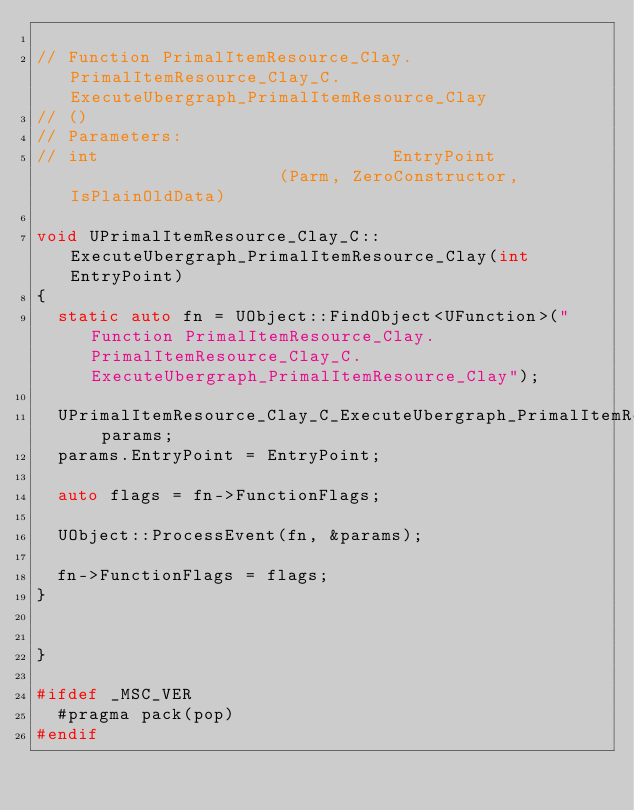<code> <loc_0><loc_0><loc_500><loc_500><_C++_>
// Function PrimalItemResource_Clay.PrimalItemResource_Clay_C.ExecuteUbergraph_PrimalItemResource_Clay
// ()
// Parameters:
// int                            EntryPoint                     (Parm, ZeroConstructor, IsPlainOldData)

void UPrimalItemResource_Clay_C::ExecuteUbergraph_PrimalItemResource_Clay(int EntryPoint)
{
	static auto fn = UObject::FindObject<UFunction>("Function PrimalItemResource_Clay.PrimalItemResource_Clay_C.ExecuteUbergraph_PrimalItemResource_Clay");

	UPrimalItemResource_Clay_C_ExecuteUbergraph_PrimalItemResource_Clay_Params params;
	params.EntryPoint = EntryPoint;

	auto flags = fn->FunctionFlags;

	UObject::ProcessEvent(fn, &params);

	fn->FunctionFlags = flags;
}


}

#ifdef _MSC_VER
	#pragma pack(pop)
#endif
</code> 